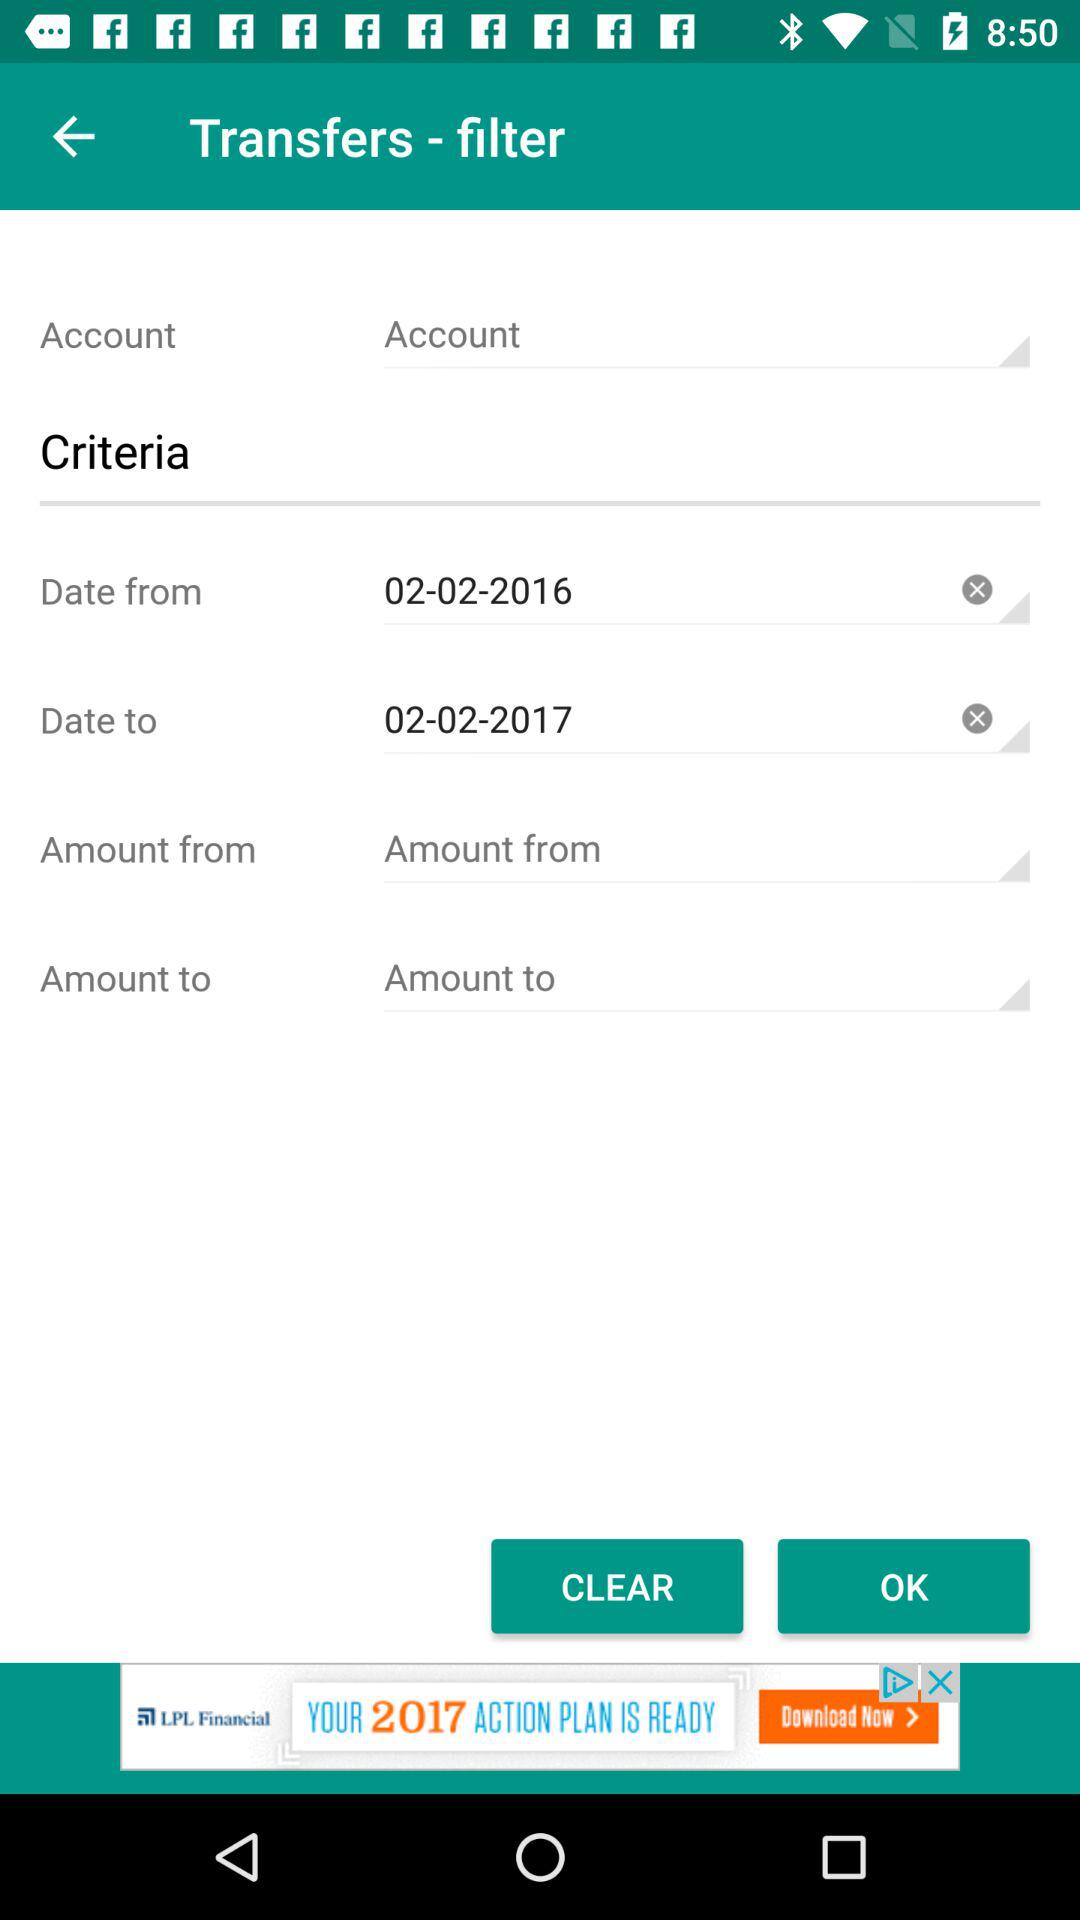Which dates were chosen for the duration?
When the provided information is insufficient, respond with <no answer>. <no answer> 